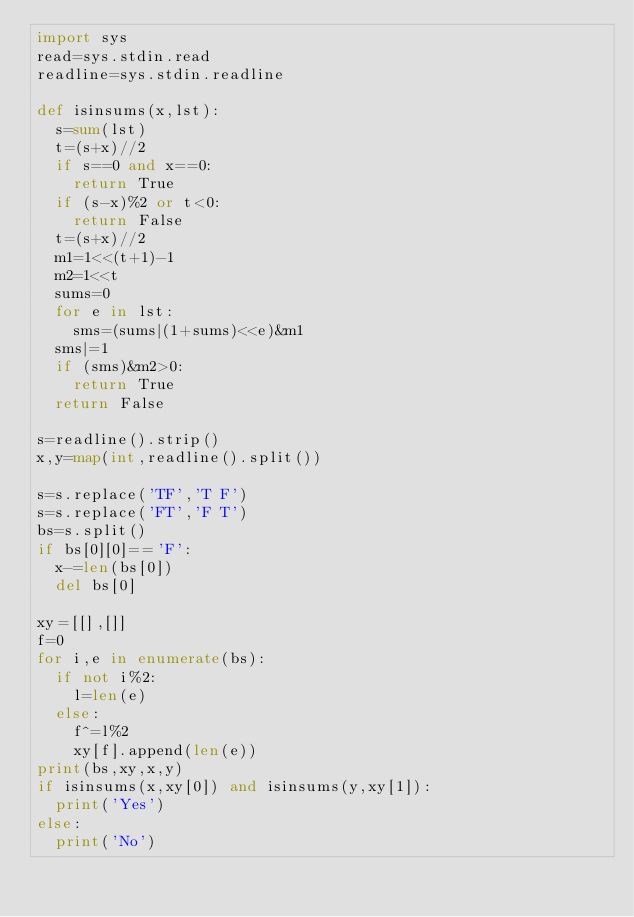Convert code to text. <code><loc_0><loc_0><loc_500><loc_500><_Python_>import sys
read=sys.stdin.read
readline=sys.stdin.readline

def isinsums(x,lst):
  s=sum(lst)
  t=(s+x)//2
  if s==0 and x==0:
    return True
  if (s-x)%2 or t<0:
    return False
  t=(s+x)//2
  m1=1<<(t+1)-1
  m2=1<<t
  sums=0
  for e in lst:
    sms=(sums|(1+sums)<<e)&m1
  sms|=1
  if (sms)&m2>0:
    return True
  return False

s=readline().strip()
x,y=map(int,readline().split())

s=s.replace('TF','T F')
s=s.replace('FT','F T')
bs=s.split()
if bs[0][0]=='F':
  x-=len(bs[0])
  del bs[0]

xy=[[],[]]
f=0
for i,e in enumerate(bs):
  if not i%2:
    l=len(e)
  else:
    f^=l%2
    xy[f].append(len(e))
print(bs,xy,x,y)
if isinsums(x,xy[0]) and isinsums(y,xy[1]):
  print('Yes')
else:
  print('No')
</code> 